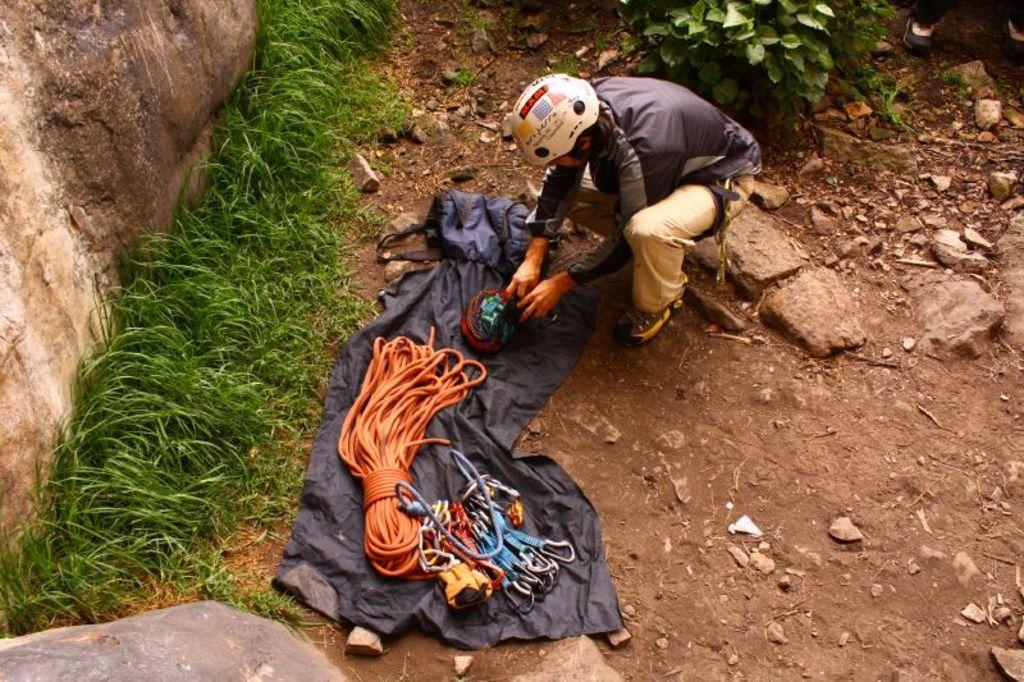How would you summarize this image in a sentence or two? In the center of the image we can see person, cloth , rope and some objects. On the right side of the image there are stones and tree. On the left side we can see rocks and grass. 